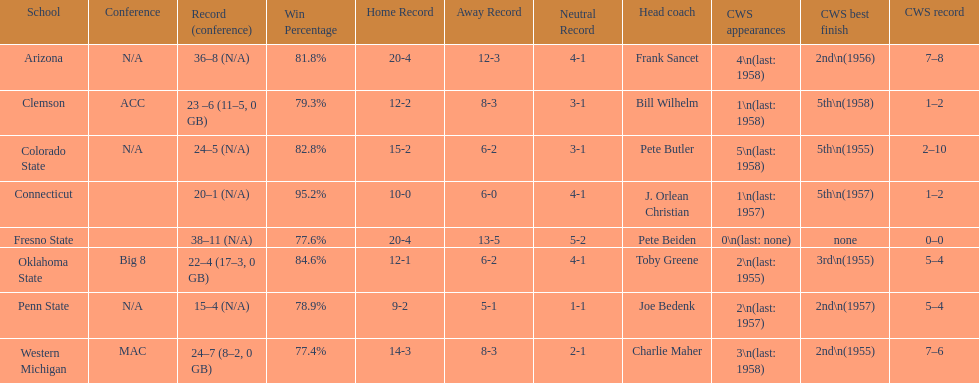Which was the only team with less than 20 wins? Penn State. 